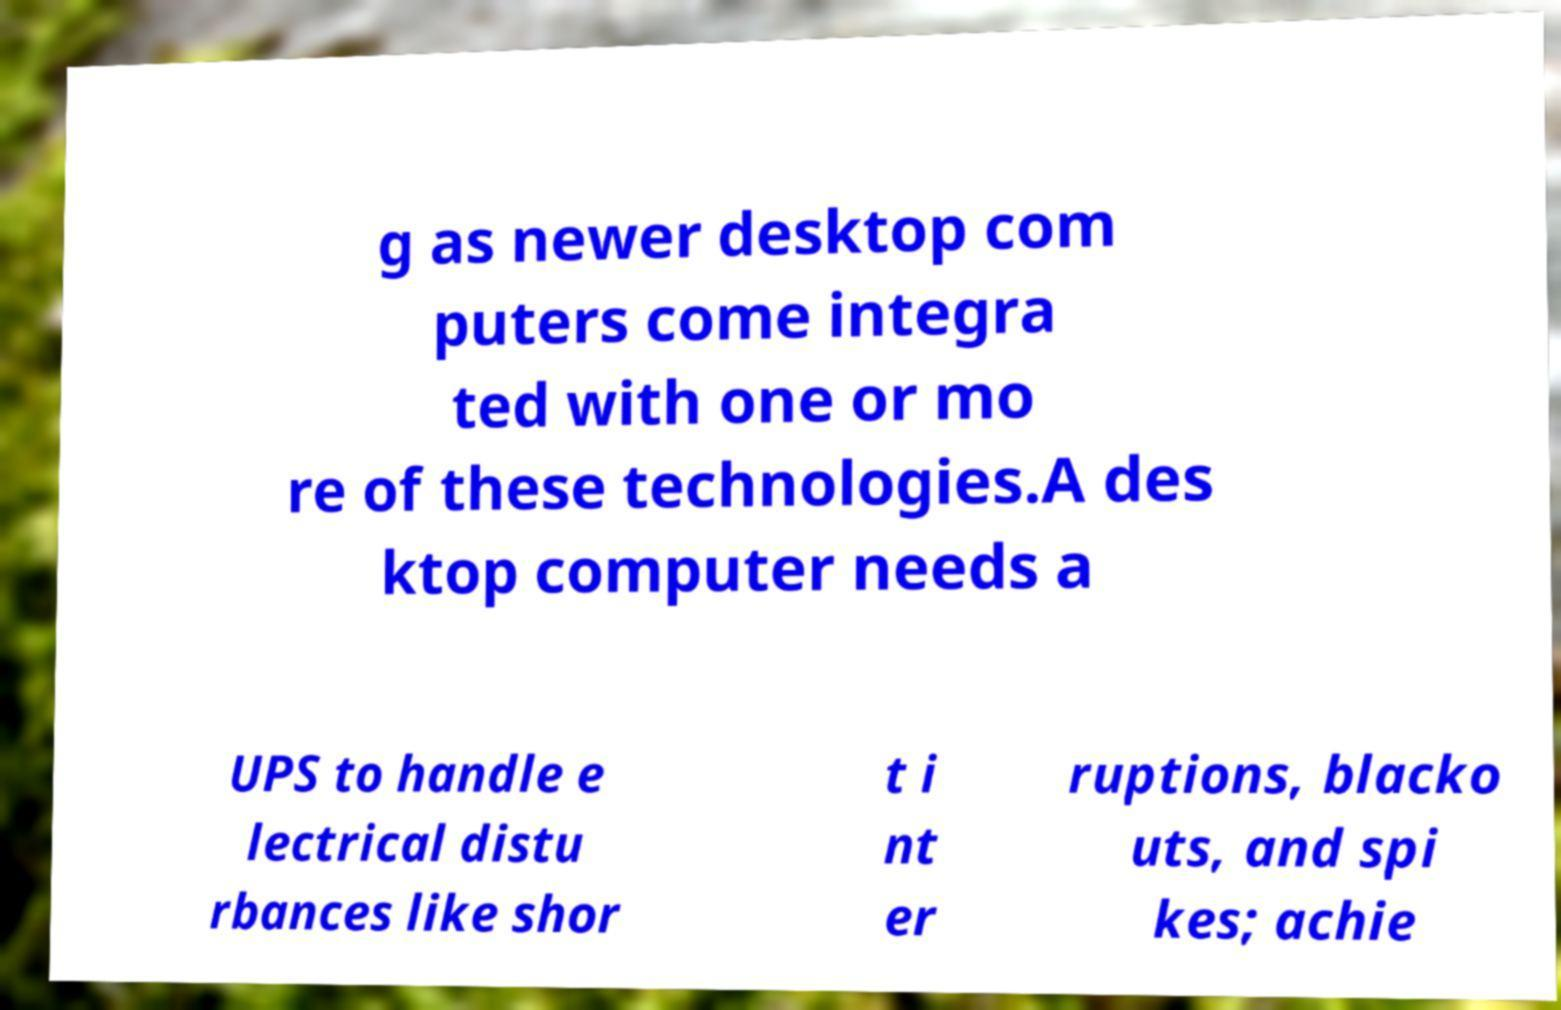Could you assist in decoding the text presented in this image and type it out clearly? g as newer desktop com puters come integra ted with one or mo re of these technologies.A des ktop computer needs a UPS to handle e lectrical distu rbances like shor t i nt er ruptions, blacko uts, and spi kes; achie 